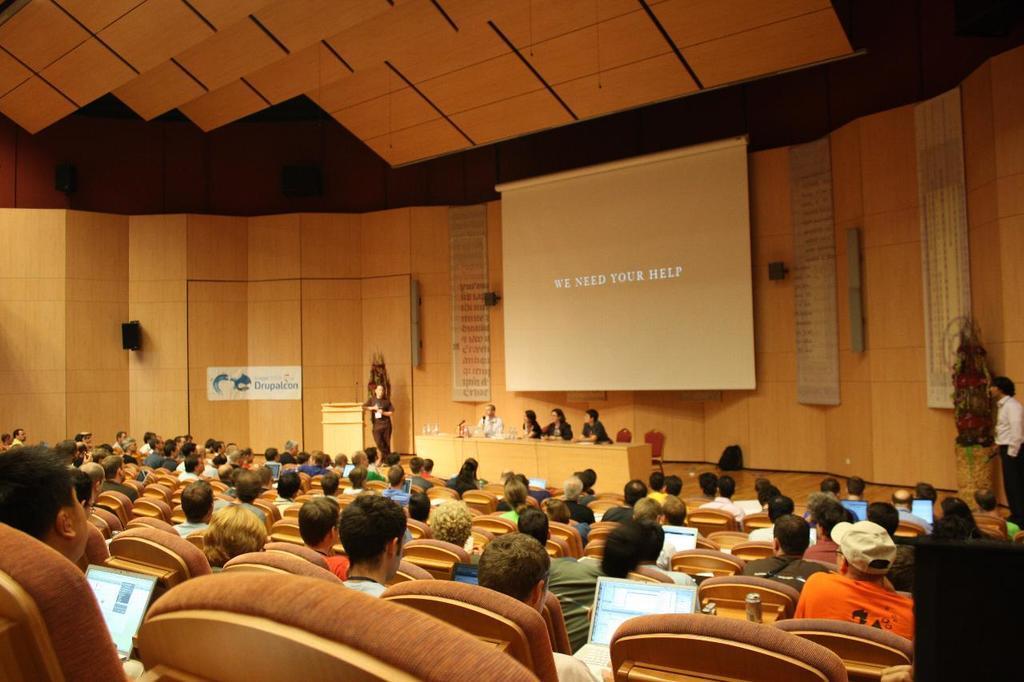Can you describe this image briefly? This image is taken in a conference hall. In this image there are a few people sitting on the chairs and they are placed there laptops on their laps. In front of them there is a person standing on the stage and few are sitting in front of the table with some stuff on it. In the background there is a wall and a screen hanging on it. At the top of the image there is a ceiling. 